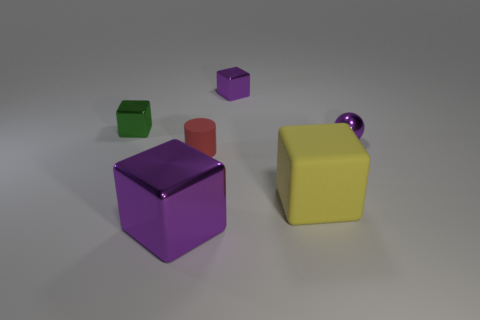Add 1 small green rubber spheres. How many objects exist? 7 Subtract all cubes. How many objects are left? 2 Subtract 0 brown cylinders. How many objects are left? 6 Subtract all tiny gray blocks. Subtract all rubber cylinders. How many objects are left? 5 Add 3 small cylinders. How many small cylinders are left? 4 Add 6 green things. How many green things exist? 7 